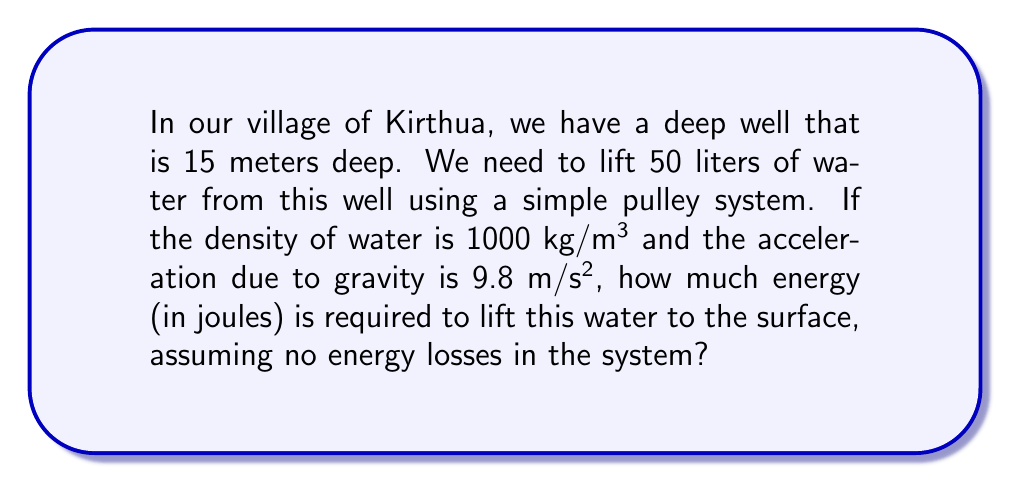Provide a solution to this math problem. To solve this problem, we'll follow these steps:

1. Calculate the mass of water:
   Volume of water = 50 liters = 0.05 m³
   Density of water = 1000 kg/m³
   Mass = Volume × Density
   $m = 0.05 \text{ m}^3 \times 1000 \text{ kg/m}^3 = 50 \text{ kg}$

2. Calculate the gravitational potential energy:
   The formula for gravitational potential energy is:
   $E = mgh$
   where:
   $E$ = energy (in joules)
   $m$ = mass of the object (in kg)
   $g$ = acceleration due to gravity (in m/s²)
   $h$ = height (in meters)

3. Substitute the values:
   $E = 50 \text{ kg} \times 9.8 \text{ m/s}^2 \times 15 \text{ m}$

4. Calculate the result:
   $E = 7350 \text{ J}$

Therefore, the energy required to lift 50 liters of water from a 15-meter deep well is 7350 joules.
Answer: 7350 J 